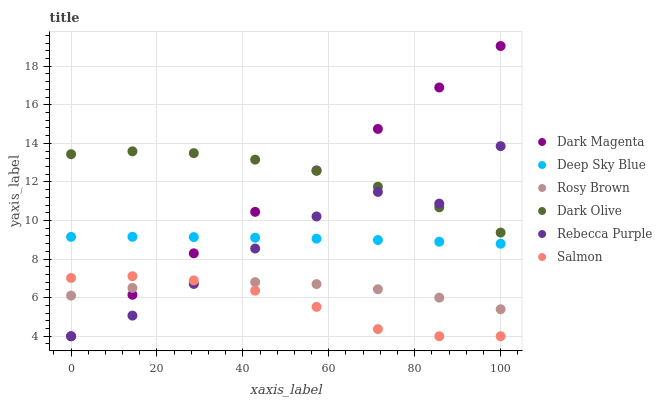Does Salmon have the minimum area under the curve?
Answer yes or no. Yes. Does Dark Olive have the maximum area under the curve?
Answer yes or no. Yes. Does Dark Magenta have the minimum area under the curve?
Answer yes or no. No. Does Dark Magenta have the maximum area under the curve?
Answer yes or no. No. Is Dark Magenta the smoothest?
Answer yes or no. Yes. Is Rebecca Purple the roughest?
Answer yes or no. Yes. Is Dark Olive the smoothest?
Answer yes or no. No. Is Dark Olive the roughest?
Answer yes or no. No. Does Dark Magenta have the lowest value?
Answer yes or no. Yes. Does Dark Olive have the lowest value?
Answer yes or no. No. Does Dark Magenta have the highest value?
Answer yes or no. Yes. Does Dark Olive have the highest value?
Answer yes or no. No. Is Rosy Brown less than Deep Sky Blue?
Answer yes or no. Yes. Is Deep Sky Blue greater than Salmon?
Answer yes or no. Yes. Does Deep Sky Blue intersect Rebecca Purple?
Answer yes or no. Yes. Is Deep Sky Blue less than Rebecca Purple?
Answer yes or no. No. Is Deep Sky Blue greater than Rebecca Purple?
Answer yes or no. No. Does Rosy Brown intersect Deep Sky Blue?
Answer yes or no. No. 